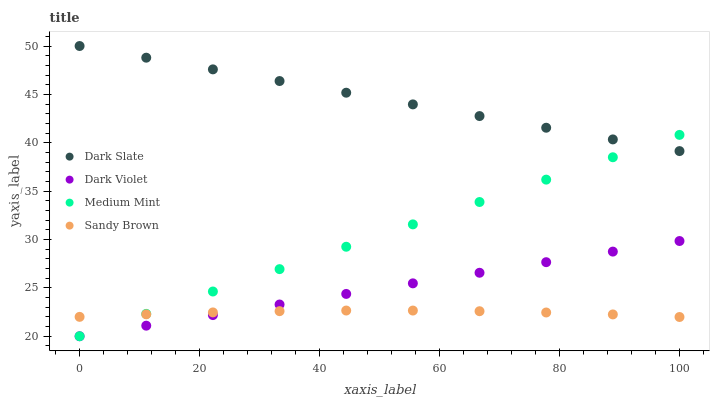Does Sandy Brown have the minimum area under the curve?
Answer yes or no. Yes. Does Dark Slate have the maximum area under the curve?
Answer yes or no. Yes. Does Dark Slate have the minimum area under the curve?
Answer yes or no. No. Does Sandy Brown have the maximum area under the curve?
Answer yes or no. No. Is Dark Violet the smoothest?
Answer yes or no. Yes. Is Sandy Brown the roughest?
Answer yes or no. Yes. Is Dark Slate the smoothest?
Answer yes or no. No. Is Dark Slate the roughest?
Answer yes or no. No. Does Medium Mint have the lowest value?
Answer yes or no. Yes. Does Sandy Brown have the lowest value?
Answer yes or no. No. Does Dark Slate have the highest value?
Answer yes or no. Yes. Does Sandy Brown have the highest value?
Answer yes or no. No. Is Dark Violet less than Dark Slate?
Answer yes or no. Yes. Is Dark Slate greater than Sandy Brown?
Answer yes or no. Yes. Does Sandy Brown intersect Dark Violet?
Answer yes or no. Yes. Is Sandy Brown less than Dark Violet?
Answer yes or no. No. Is Sandy Brown greater than Dark Violet?
Answer yes or no. No. Does Dark Violet intersect Dark Slate?
Answer yes or no. No. 